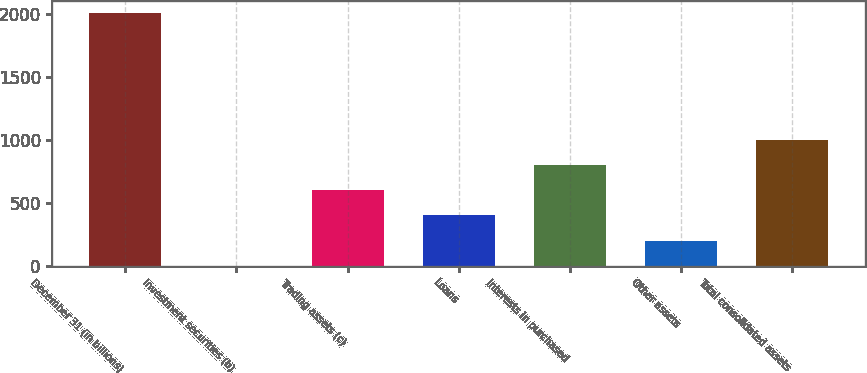Convert chart. <chart><loc_0><loc_0><loc_500><loc_500><bar_chart><fcel>December 31 (in billions)<fcel>Investment securities (b)<fcel>Trading assets (c)<fcel>Loans<fcel>Interests in purchased<fcel>Other assets<fcel>Total consolidated assets<nl><fcel>2005<fcel>1.9<fcel>602.83<fcel>402.52<fcel>803.14<fcel>202.21<fcel>1003.45<nl></chart> 